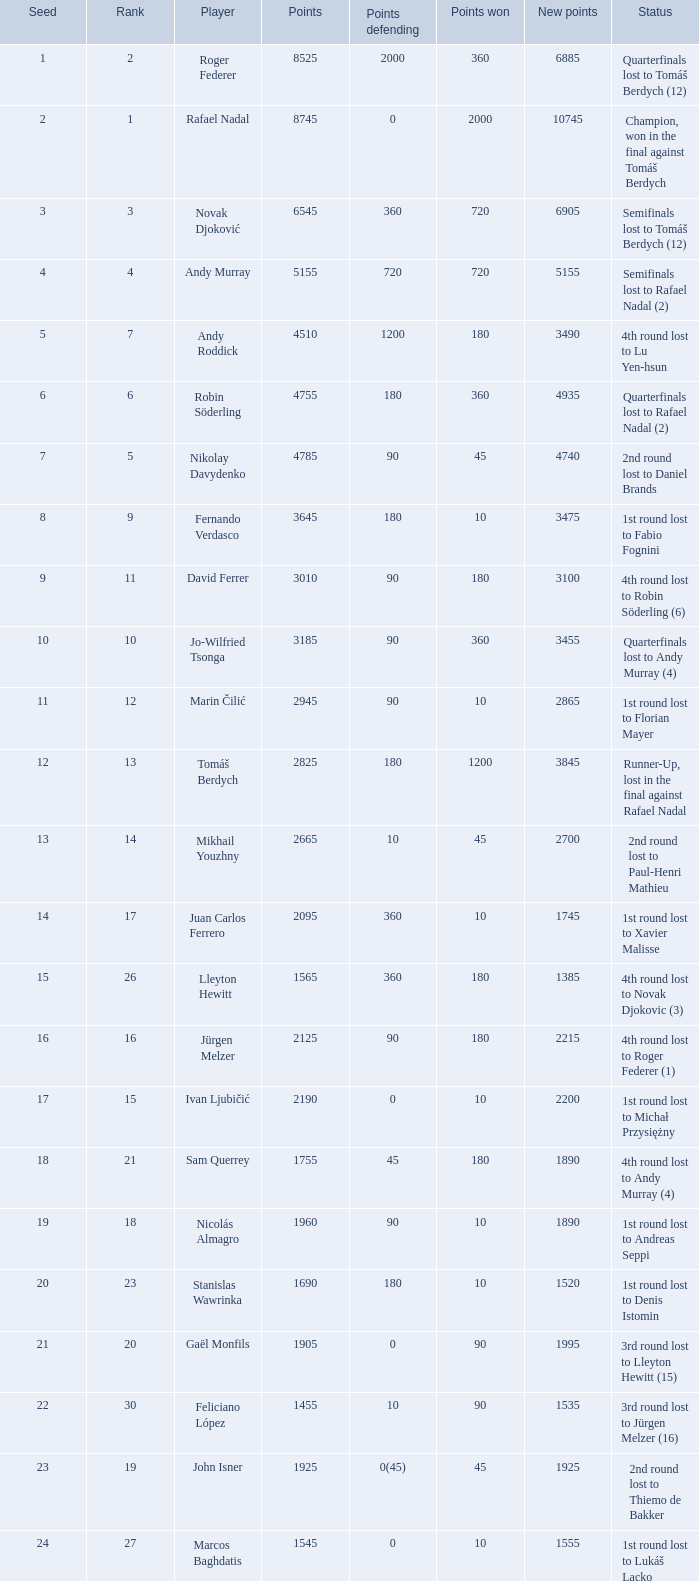Indicate the points gained for 1230 90.0. Help me parse the entirety of this table. {'header': ['Seed', 'Rank', 'Player', 'Points', 'Points defending', 'Points won', 'New points', 'Status'], 'rows': [['1', '2', 'Roger Federer', '8525', '2000', '360', '6885', 'Quarterfinals lost to Tomáš Berdych (12)'], ['2', '1', 'Rafael Nadal', '8745', '0', '2000', '10745', 'Champion, won in the final against Tomáš Berdych'], ['3', '3', 'Novak Djoković', '6545', '360', '720', '6905', 'Semifinals lost to Tomáš Berdych (12)'], ['4', '4', 'Andy Murray', '5155', '720', '720', '5155', 'Semifinals lost to Rafael Nadal (2)'], ['5', '7', 'Andy Roddick', '4510', '1200', '180', '3490', '4th round lost to Lu Yen-hsun'], ['6', '6', 'Robin Söderling', '4755', '180', '360', '4935', 'Quarterfinals lost to Rafael Nadal (2)'], ['7', '5', 'Nikolay Davydenko', '4785', '90', '45', '4740', '2nd round lost to Daniel Brands'], ['8', '9', 'Fernando Verdasco', '3645', '180', '10', '3475', '1st round lost to Fabio Fognini'], ['9', '11', 'David Ferrer', '3010', '90', '180', '3100', '4th round lost to Robin Söderling (6)'], ['10', '10', 'Jo-Wilfried Tsonga', '3185', '90', '360', '3455', 'Quarterfinals lost to Andy Murray (4)'], ['11', '12', 'Marin Čilić', '2945', '90', '10', '2865', '1st round lost to Florian Mayer'], ['12', '13', 'Tomáš Berdych', '2825', '180', '1200', '3845', 'Runner-Up, lost in the final against Rafael Nadal'], ['13', '14', 'Mikhail Youzhny', '2665', '10', '45', '2700', '2nd round lost to Paul-Henri Mathieu'], ['14', '17', 'Juan Carlos Ferrero', '2095', '360', '10', '1745', '1st round lost to Xavier Malisse'], ['15', '26', 'Lleyton Hewitt', '1565', '360', '180', '1385', '4th round lost to Novak Djokovic (3)'], ['16', '16', 'Jürgen Melzer', '2125', '90', '180', '2215', '4th round lost to Roger Federer (1)'], ['17', '15', 'Ivan Ljubičić', '2190', '0', '10', '2200', '1st round lost to Michał Przysiężny'], ['18', '21', 'Sam Querrey', '1755', '45', '180', '1890', '4th round lost to Andy Murray (4)'], ['19', '18', 'Nicolás Almagro', '1960', '90', '10', '1890', '1st round lost to Andreas Seppi'], ['20', '23', 'Stanislas Wawrinka', '1690', '180', '10', '1520', '1st round lost to Denis Istomin'], ['21', '20', 'Gaël Monfils', '1905', '0', '90', '1995', '3rd round lost to Lleyton Hewitt (15)'], ['22', '30', 'Feliciano López', '1455', '10', '90', '1535', '3rd round lost to Jürgen Melzer (16)'], ['23', '19', 'John Isner', '1925', '0(45)', '45', '1925', '2nd round lost to Thiemo de Bakker'], ['24', '27', 'Marcos Baghdatis', '1545', '0', '10', '1555', '1st round lost to Lukáš Lacko'], ['25', '24', 'Thomaz Bellucci', '1652', '0(20)', '90', '1722', '3rd round lost to Robin Söderling (6)'], ['26', '32', 'Gilles Simon', '1305', '180', '90', '1215', '3rd round lost to Andy Murray (4)'], ['28', '31', 'Albert Montañés', '1405', '90', '90', '1405', '3rd round lost to Novak Djokovic (3)'], ['29', '35', 'Philipp Kohlschreiber', '1230', '90', '90', '1230', '3rd round lost to Andy Roddick (5)'], ['30', '36', 'Tommy Robredo', '1155', '90', '10', '1075', '1st round lost to Peter Luczak'], ['31', '37', 'Victor Hănescu', '1070', '45', '90', '1115', '3rd round lost to Daniel Brands'], ['32', '38', 'Julien Benneteau', '1059', '10', '180', '1229', '4th round lost to Jo-Wilfried Tsonga (10)']]} 